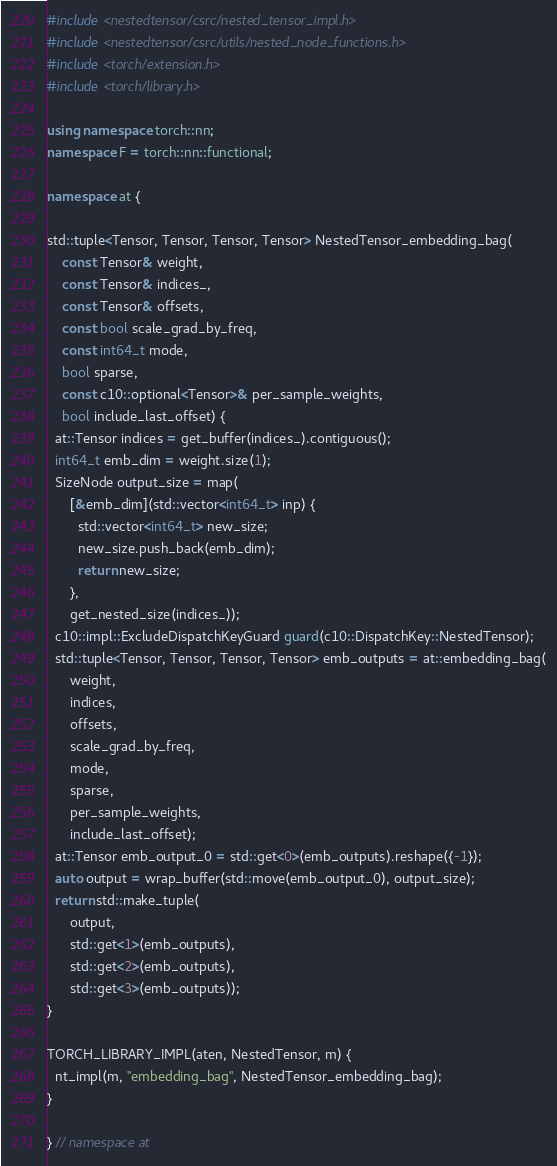<code> <loc_0><loc_0><loc_500><loc_500><_C++_>#include <nestedtensor/csrc/nested_tensor_impl.h>
#include <nestedtensor/csrc/utils/nested_node_functions.h>
#include <torch/extension.h>
#include <torch/library.h>

using namespace torch::nn;
namespace F = torch::nn::functional;

namespace at {

std::tuple<Tensor, Tensor, Tensor, Tensor> NestedTensor_embedding_bag(
    const Tensor& weight,
    const Tensor& indices_,
    const Tensor& offsets,
    const bool scale_grad_by_freq,
    const int64_t mode,
    bool sparse,
    const c10::optional<Tensor>& per_sample_weights,
    bool include_last_offset) {
  at::Tensor indices = get_buffer(indices_).contiguous();
  int64_t emb_dim = weight.size(1);
  SizeNode output_size = map(
      [&emb_dim](std::vector<int64_t> inp) {
        std::vector<int64_t> new_size;
        new_size.push_back(emb_dim);
        return new_size;
      },
      get_nested_size(indices_));
  c10::impl::ExcludeDispatchKeyGuard guard(c10::DispatchKey::NestedTensor);
  std::tuple<Tensor, Tensor, Tensor, Tensor> emb_outputs = at::embedding_bag(
      weight,
      indices,
      offsets,
      scale_grad_by_freq,
      mode,
      sparse,
      per_sample_weights,
      include_last_offset);
  at::Tensor emb_output_0 = std::get<0>(emb_outputs).reshape({-1});
  auto output = wrap_buffer(std::move(emb_output_0), output_size);
  return std::make_tuple(
      output,
      std::get<1>(emb_outputs),
      std::get<2>(emb_outputs),
      std::get<3>(emb_outputs));
}

TORCH_LIBRARY_IMPL(aten, NestedTensor, m) {
  nt_impl(m, "embedding_bag", NestedTensor_embedding_bag);
}

} // namespace at
</code> 